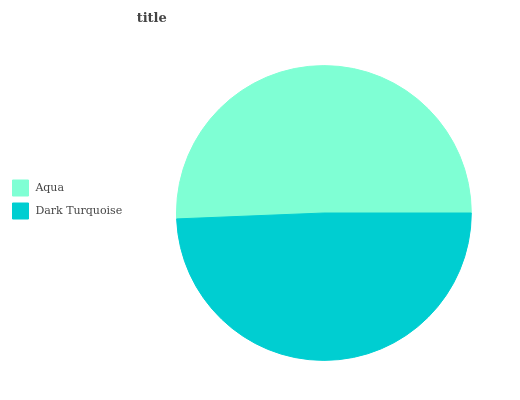Is Dark Turquoise the minimum?
Answer yes or no. Yes. Is Aqua the maximum?
Answer yes or no. Yes. Is Dark Turquoise the maximum?
Answer yes or no. No. Is Aqua greater than Dark Turquoise?
Answer yes or no. Yes. Is Dark Turquoise less than Aqua?
Answer yes or no. Yes. Is Dark Turquoise greater than Aqua?
Answer yes or no. No. Is Aqua less than Dark Turquoise?
Answer yes or no. No. Is Aqua the high median?
Answer yes or no. Yes. Is Dark Turquoise the low median?
Answer yes or no. Yes. Is Dark Turquoise the high median?
Answer yes or no. No. Is Aqua the low median?
Answer yes or no. No. 